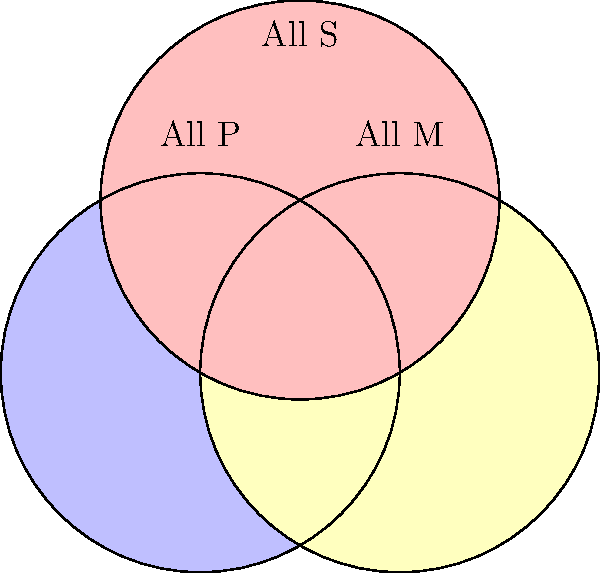Analyze the validity of the following syllogism using the Venn diagram above:

Premise 1: All P are M
Premise 2: All S are P
Conclusion: All S are M

Is this syllogism valid? Justify your answer using the Venn diagram representation. To analyze the validity of the syllogism using the Venn diagram, we'll follow these steps:

1. Interpret the premises:
   - "All P are M" means the P circle should be entirely within the M circle.
   - "All S are P" means the S circle should be entirely within the P circle.

2. Represent the premises on the diagram:
   - The P circle (blue) should be inside the M circle (yellow).
   - The S circle (red) should be inside the P circle (blue).

3. Examine the conclusion:
   - "All S are M" means we need to check if the S circle is entirely within the M circle.

4. Analyze the diagram:
   - We can see that if S is entirely within P, and P is entirely within M, then S must be entirely within M.
   - This is because the S circle (red) is contained within the P circle (blue), which is in turn contained within the M circle (yellow).

5. Logical deduction:
   - The transitive property of set inclusion applies here: if S ⊆ P and P ⊆ M, then S ⊆ M.

6. Conclusion:
   - The Venn diagram confirms that the conclusion "All S are M" necessarily follows from the premises.

Therefore, the syllogism is valid according to the Venn diagram representation.
Answer: Valid; S ⊆ P ∧ P ⊆ M ⇒ S ⊆ M 